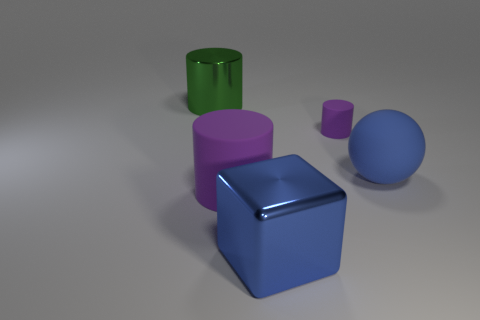How many purple cylinders must be subtracted to get 1 purple cylinders? 1 Subtract all spheres. How many objects are left? 4 Subtract 2 cylinders. How many cylinders are left? 1 Subtract all purple cubes. Subtract all yellow cylinders. How many cubes are left? 1 Subtract all purple cylinders. How many yellow blocks are left? 0 Subtract all blue shiny objects. Subtract all blue things. How many objects are left? 2 Add 1 large blue spheres. How many large blue spheres are left? 2 Add 4 yellow metal objects. How many yellow metal objects exist? 4 Add 2 blocks. How many objects exist? 7 Subtract all green cylinders. How many cylinders are left? 2 